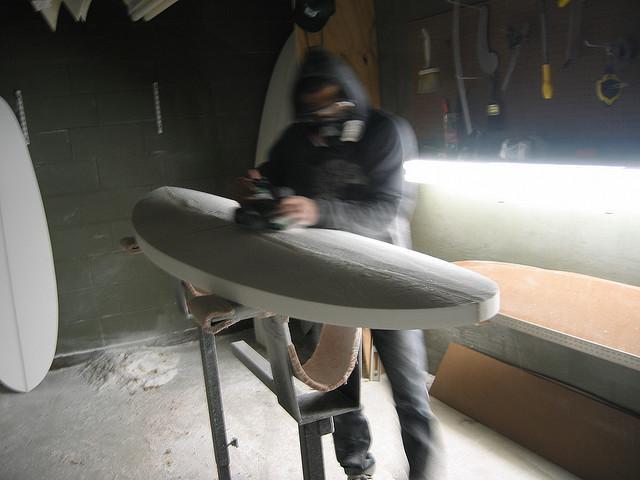How many surfboards can be seen?
Give a very brief answer. 2. 